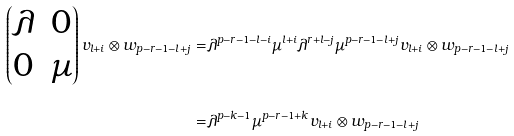Convert formula to latex. <formula><loc_0><loc_0><loc_500><loc_500>\begin{pmatrix} \lambda & 0 \\ 0 & \mu \end{pmatrix} v _ { l + i } \otimes w _ { p - r - 1 - l + j } = & \lambda ^ { p - r - 1 - l - i } \mu ^ { l + i } \lambda ^ { r + l - j } \mu ^ { p - r - 1 - l + j } v _ { l + i } \otimes w _ { p - r - 1 - l + j } \\ = & \lambda ^ { p - k - 1 } \mu ^ { p - r - 1 + k } v _ { l + i } \otimes w _ { p - r - 1 - l + j }</formula> 